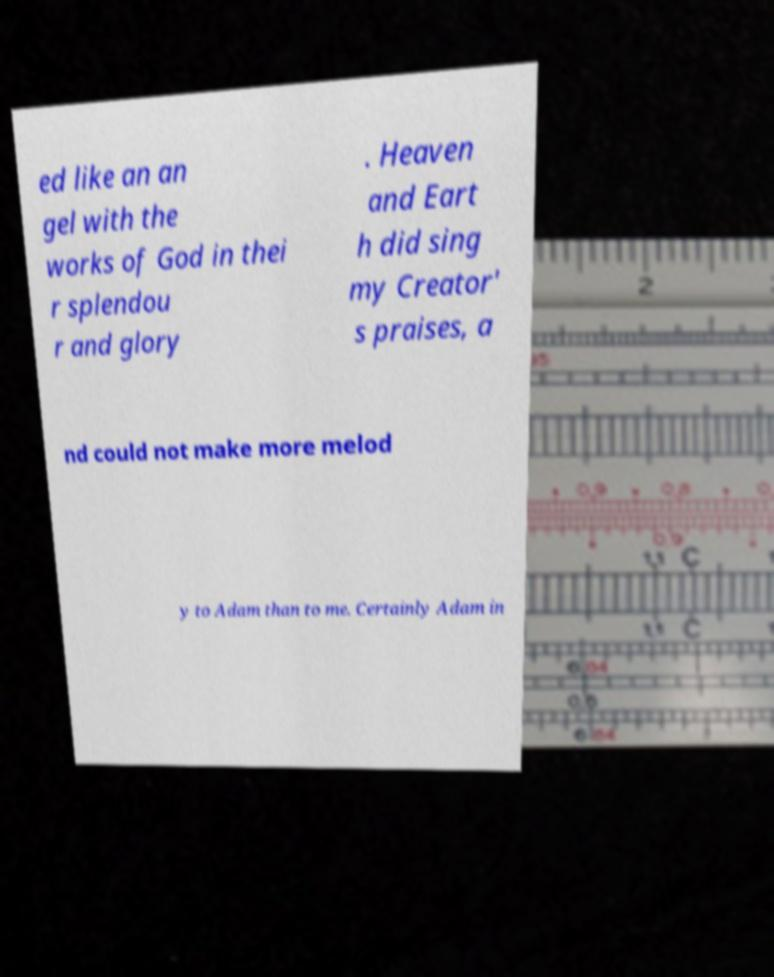Could you assist in decoding the text presented in this image and type it out clearly? ed like an an gel with the works of God in thei r splendou r and glory . Heaven and Eart h did sing my Creator' s praises, a nd could not make more melod y to Adam than to me. Certainly Adam in 